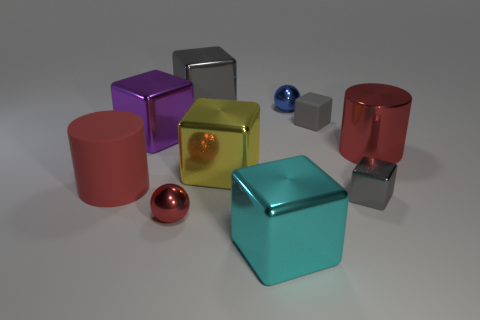How many things are either tiny gray rubber cubes or gray cubes?
Keep it short and to the point. 3. There is a big object that is both in front of the large yellow cube and on the left side of the red shiny sphere; what is its shape?
Offer a terse response. Cylinder. Is the cylinder that is on the left side of the big purple thing made of the same material as the yellow cube?
Your answer should be very brief. No. What number of objects are metallic cubes or large blocks behind the large red metal cylinder?
Provide a succinct answer. 5. What color is the tiny block that is made of the same material as the large purple block?
Provide a succinct answer. Gray. What number of large objects are the same material as the small red sphere?
Keep it short and to the point. 5. What number of cylinders are there?
Offer a very short reply. 2. There is a shiny sphere that is in front of the rubber cube; is its color the same as the large thing that is on the right side of the cyan cube?
Give a very brief answer. Yes. What number of big matte cylinders are to the right of the metallic cylinder?
Provide a succinct answer. 0. There is a tiny ball that is the same color as the large matte cylinder; what is it made of?
Make the answer very short. Metal. 